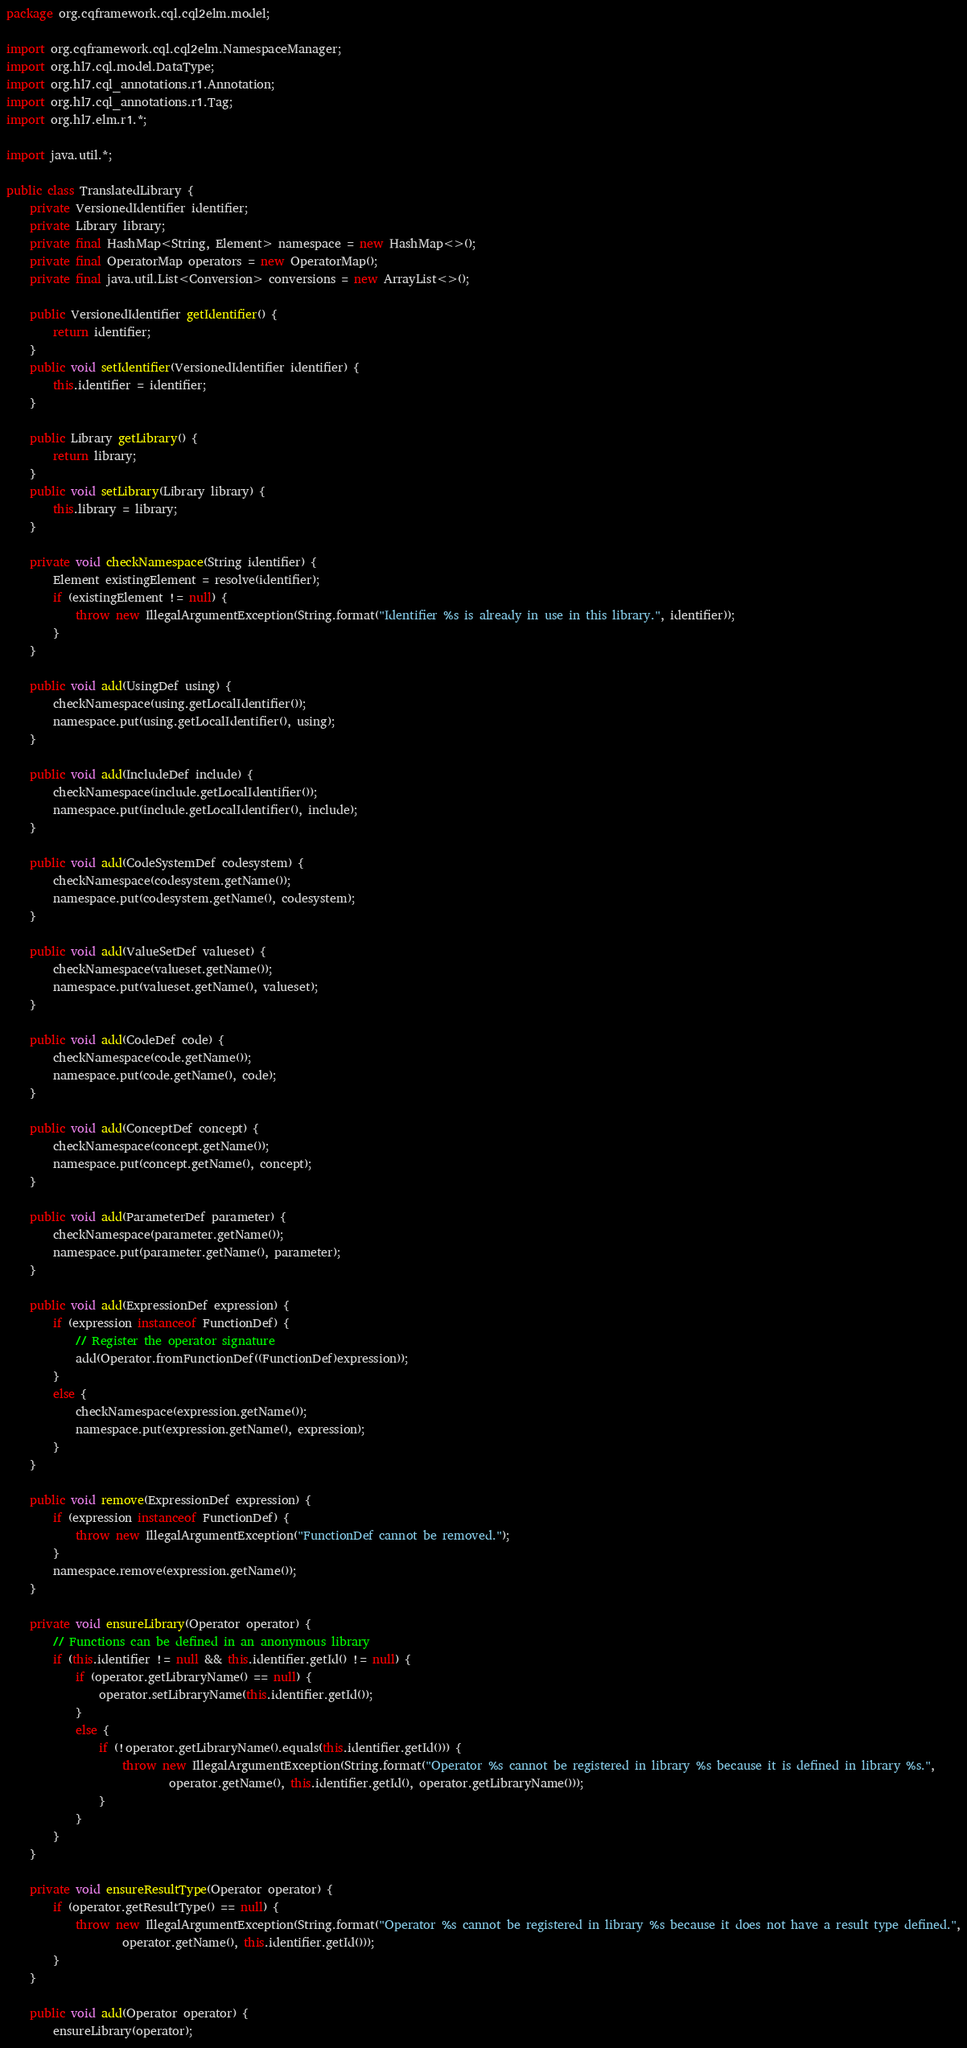Convert code to text. <code><loc_0><loc_0><loc_500><loc_500><_Java_>package org.cqframework.cql.cql2elm.model;

import org.cqframework.cql.cql2elm.NamespaceManager;
import org.hl7.cql.model.DataType;
import org.hl7.cql_annotations.r1.Annotation;
import org.hl7.cql_annotations.r1.Tag;
import org.hl7.elm.r1.*;

import java.util.*;

public class TranslatedLibrary {
    private VersionedIdentifier identifier;
    private Library library;
    private final HashMap<String, Element> namespace = new HashMap<>();
    private final OperatorMap operators = new OperatorMap();
    private final java.util.List<Conversion> conversions = new ArrayList<>();

    public VersionedIdentifier getIdentifier() {
        return identifier;
    }
    public void setIdentifier(VersionedIdentifier identifier) {
        this.identifier = identifier;
    }

    public Library getLibrary() {
        return library;
    }
    public void setLibrary(Library library) {
        this.library = library;
    }

    private void checkNamespace(String identifier) {
        Element existingElement = resolve(identifier);
        if (existingElement != null) {
            throw new IllegalArgumentException(String.format("Identifier %s is already in use in this library.", identifier));
        }
    }

    public void add(UsingDef using) {
        checkNamespace(using.getLocalIdentifier());
        namespace.put(using.getLocalIdentifier(), using);
    }

    public void add(IncludeDef include) {
        checkNamespace(include.getLocalIdentifier());
        namespace.put(include.getLocalIdentifier(), include);
    }

    public void add(CodeSystemDef codesystem) {
        checkNamespace(codesystem.getName());
        namespace.put(codesystem.getName(), codesystem);
    }

    public void add(ValueSetDef valueset) {
        checkNamespace(valueset.getName());
        namespace.put(valueset.getName(), valueset);
    }

    public void add(CodeDef code) {
        checkNamespace(code.getName());
        namespace.put(code.getName(), code);
    }

    public void add(ConceptDef concept) {
        checkNamespace(concept.getName());
        namespace.put(concept.getName(), concept);
    }

    public void add(ParameterDef parameter) {
        checkNamespace(parameter.getName());
        namespace.put(parameter.getName(), parameter);
    }

    public void add(ExpressionDef expression) {
        if (expression instanceof FunctionDef) {
            // Register the operator signature
            add(Operator.fromFunctionDef((FunctionDef)expression));
        }
        else {
            checkNamespace(expression.getName());
            namespace.put(expression.getName(), expression);
        }
    }

    public void remove(ExpressionDef expression) {
        if (expression instanceof FunctionDef) {
            throw new IllegalArgumentException("FunctionDef cannot be removed.");
        }
        namespace.remove(expression.getName());
    }

    private void ensureLibrary(Operator operator) {
        // Functions can be defined in an anonymous library
        if (this.identifier != null && this.identifier.getId() != null) {
            if (operator.getLibraryName() == null) {
                operator.setLibraryName(this.identifier.getId());
            }
            else {
                if (!operator.getLibraryName().equals(this.identifier.getId())) {
                    throw new IllegalArgumentException(String.format("Operator %s cannot be registered in library %s because it is defined in library %s.",
                            operator.getName(), this.identifier.getId(), operator.getLibraryName()));
                }
            }
        }
    }

    private void ensureResultType(Operator operator) {
        if (operator.getResultType() == null) {
            throw new IllegalArgumentException(String.format("Operator %s cannot be registered in library %s because it does not have a result type defined.",
                    operator.getName(), this.identifier.getId()));
        }
    }

    public void add(Operator operator) {
        ensureLibrary(operator);</code> 